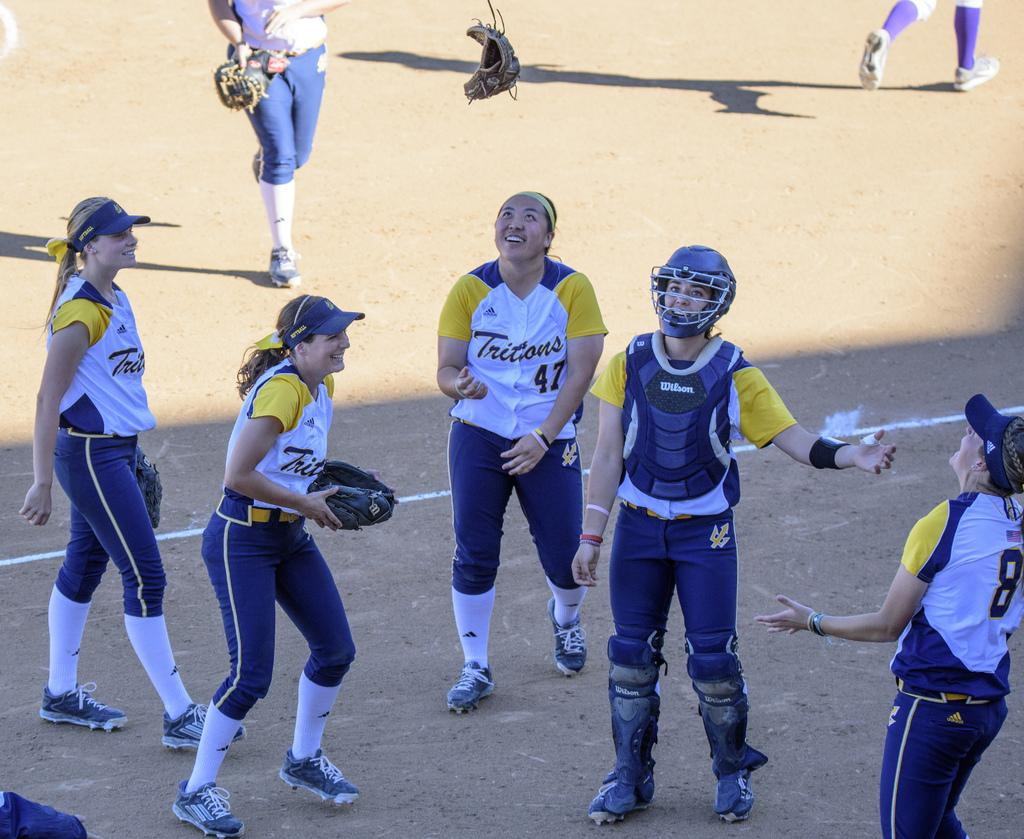Provide a one-sentence caption for the provided image. The girl in the yellow and white jersey is wearing number 47. 